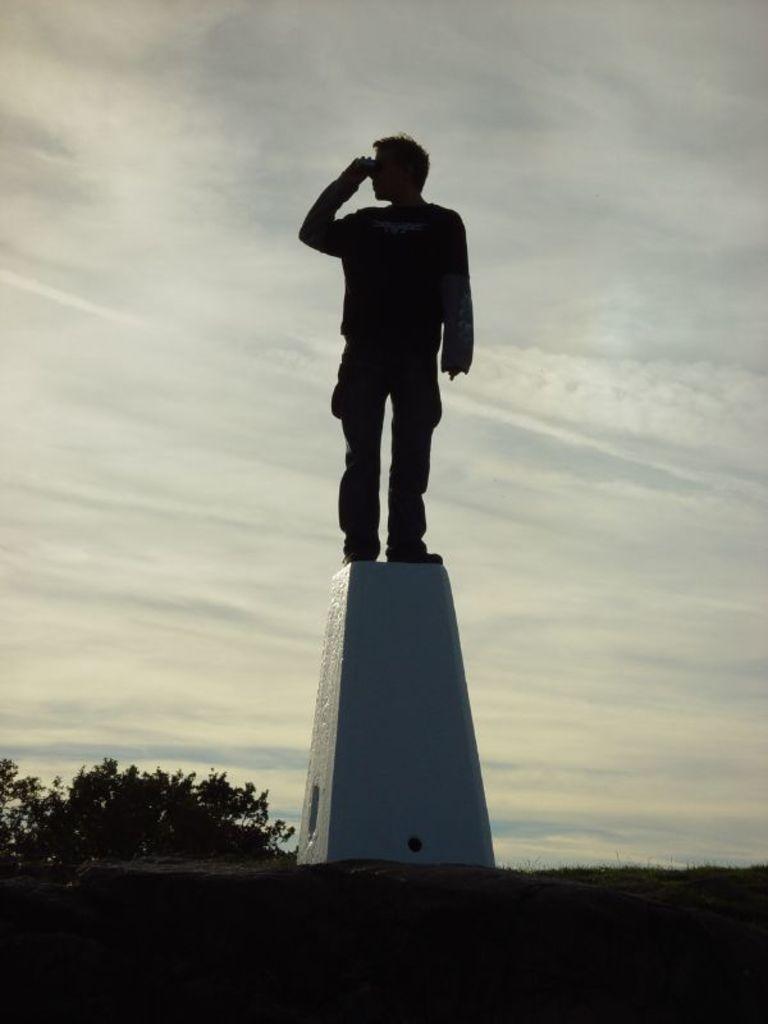How would you summarize this image in a sentence or two? This picture is clicked outside. In the center there is a person standing on a cement object. In the foreground we can see the grass and some plants. In the background there is a sky which is full of clouds. 